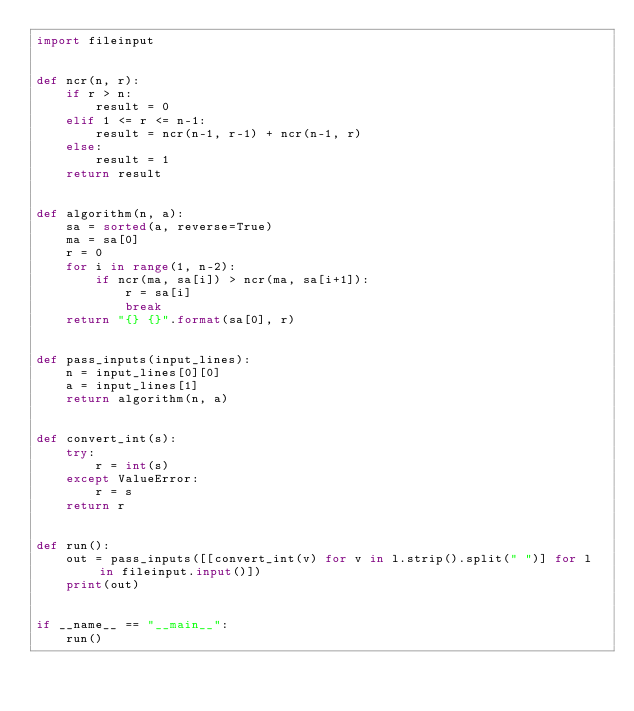<code> <loc_0><loc_0><loc_500><loc_500><_Python_>import fileinput


def ncr(n, r):
    if r > n:
        result = 0
    elif 1 <= r <= n-1:
        result = ncr(n-1, r-1) + ncr(n-1, r)
    else:
        result = 1
    return result


def algorithm(n, a):
    sa = sorted(a, reverse=True)
    ma = sa[0]
    r = 0
    for i in range(1, n-2):
        if ncr(ma, sa[i]) > ncr(ma, sa[i+1]):
            r = sa[i]
            break
    return "{} {}".format(sa[0], r)


def pass_inputs(input_lines):
    n = input_lines[0][0]
    a = input_lines[1]
    return algorithm(n, a)


def convert_int(s):
    try:
        r = int(s)
    except ValueError:
        r = s
    return r


def run():
    out = pass_inputs([[convert_int(v) for v in l.strip().split(" ")] for l in fileinput.input()])
    print(out)


if __name__ == "__main__":
    run()
</code> 